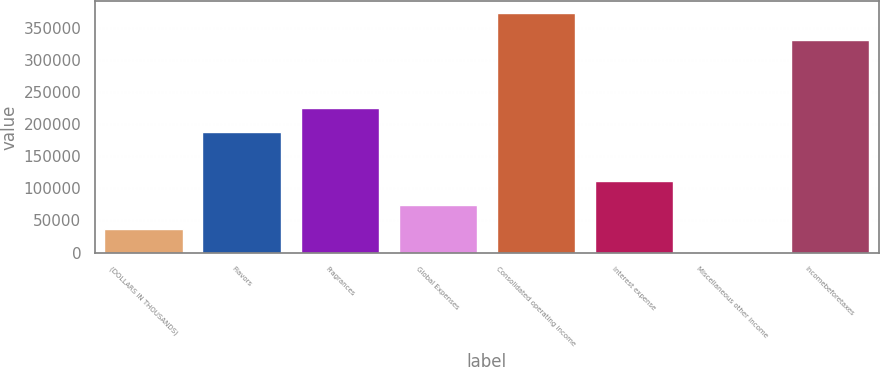<chart> <loc_0><loc_0><loc_500><loc_500><bar_chart><fcel>(DOLLARS IN THOUSANDS)<fcel>Flavors<fcel>Fragrances<fcel>Global Expenses<fcel>Consolidated operating income<fcel>Interest expense<fcel>Miscellaneous other income<fcel>Incomebeforetaxes<nl><fcel>37321.3<fcel>187275<fcel>224488<fcel>74534.6<fcel>372241<fcel>111748<fcel>108<fcel>330814<nl></chart> 